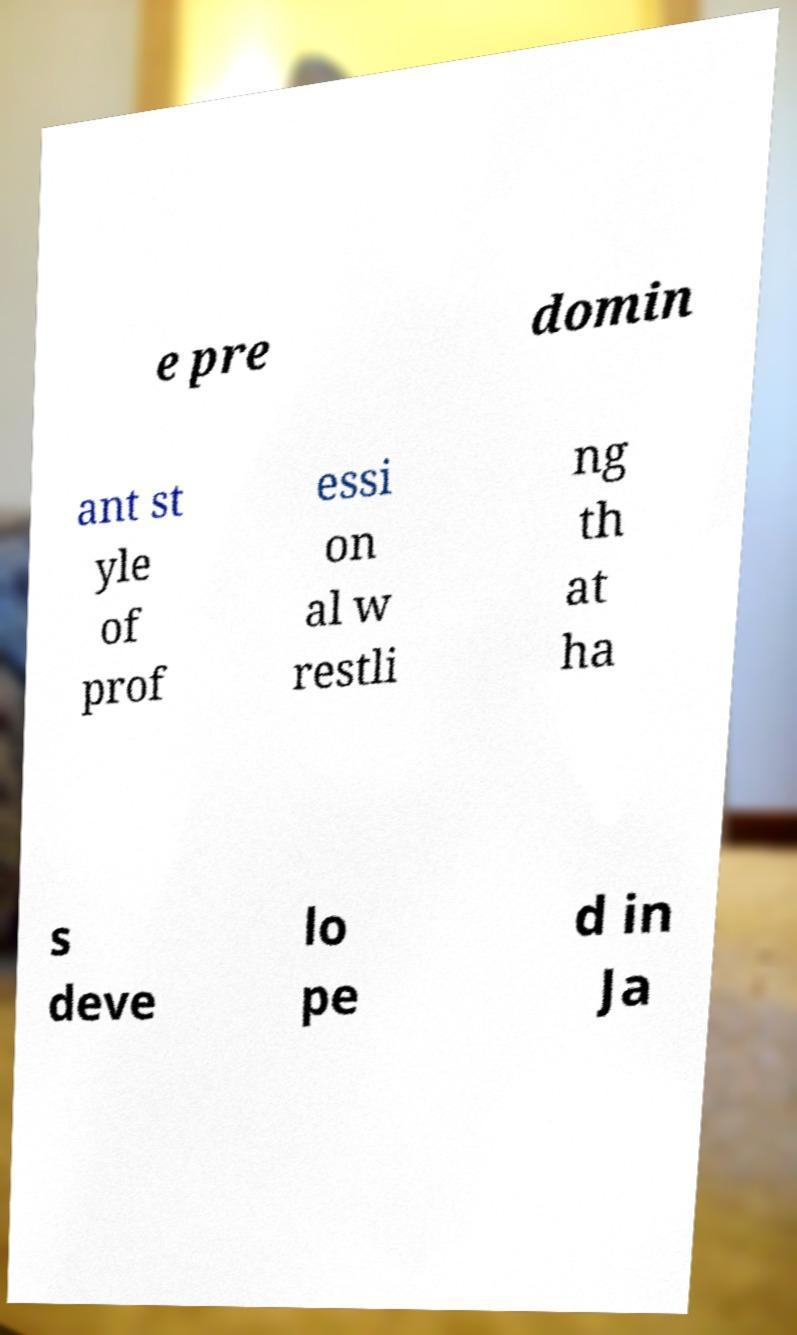What messages or text are displayed in this image? I need them in a readable, typed format. e pre domin ant st yle of prof essi on al w restli ng th at ha s deve lo pe d in Ja 